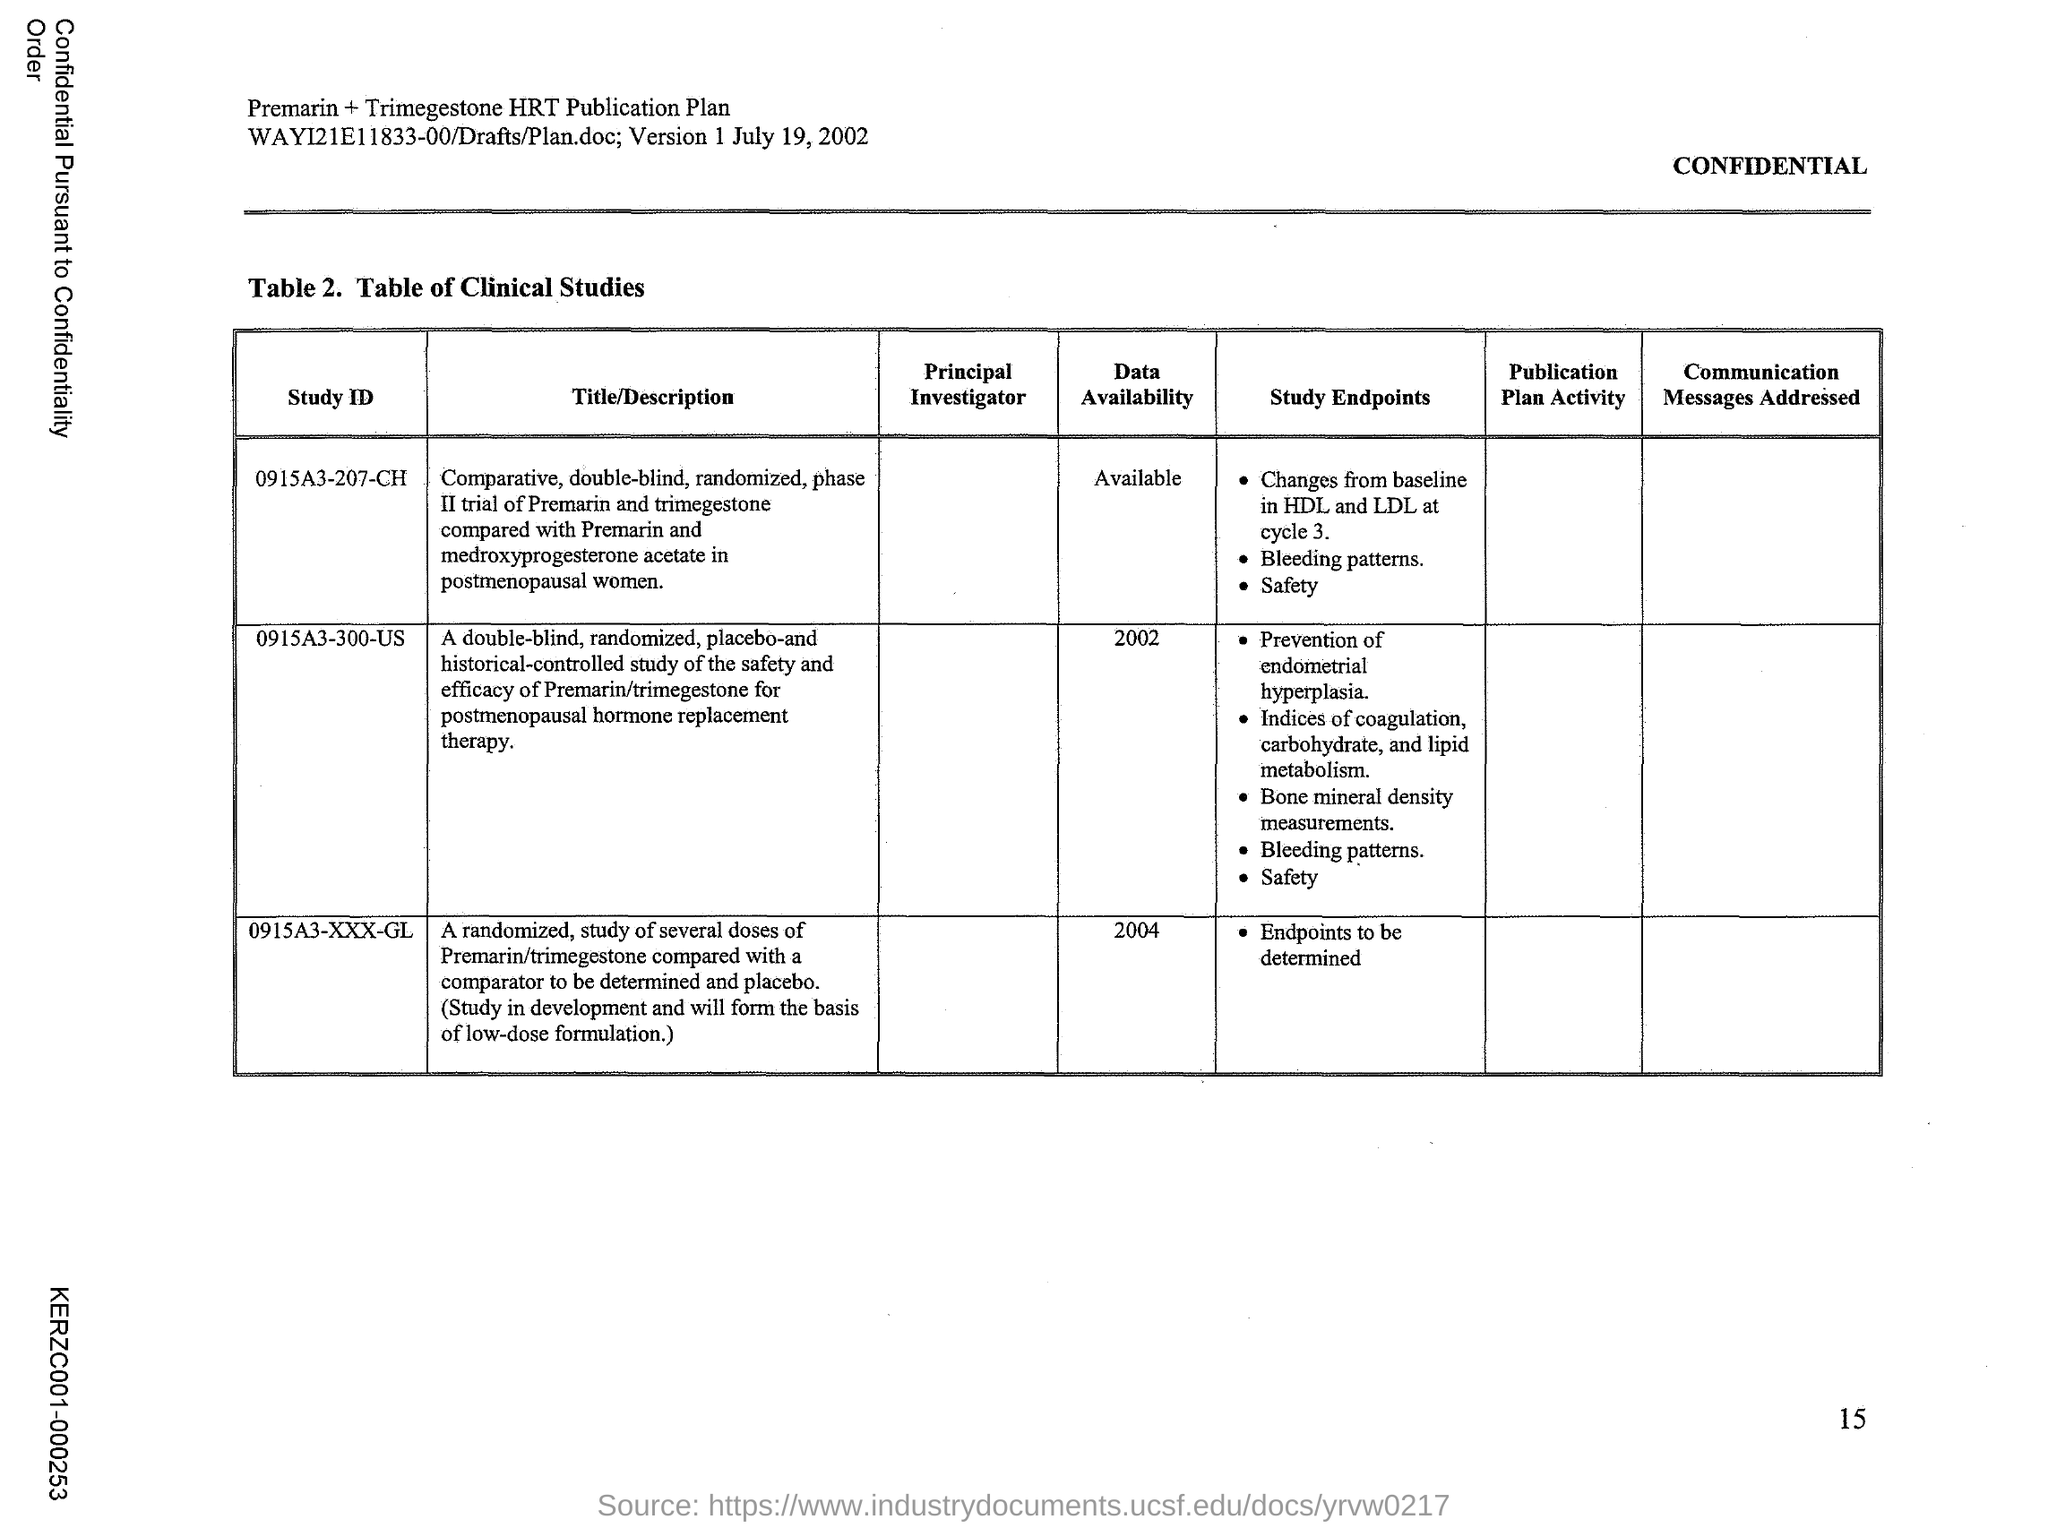Give some essential details in this illustration. Table 2 in the document represents a table of clinical studies. 